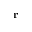<formula> <loc_0><loc_0><loc_500><loc_500>r</formula> 